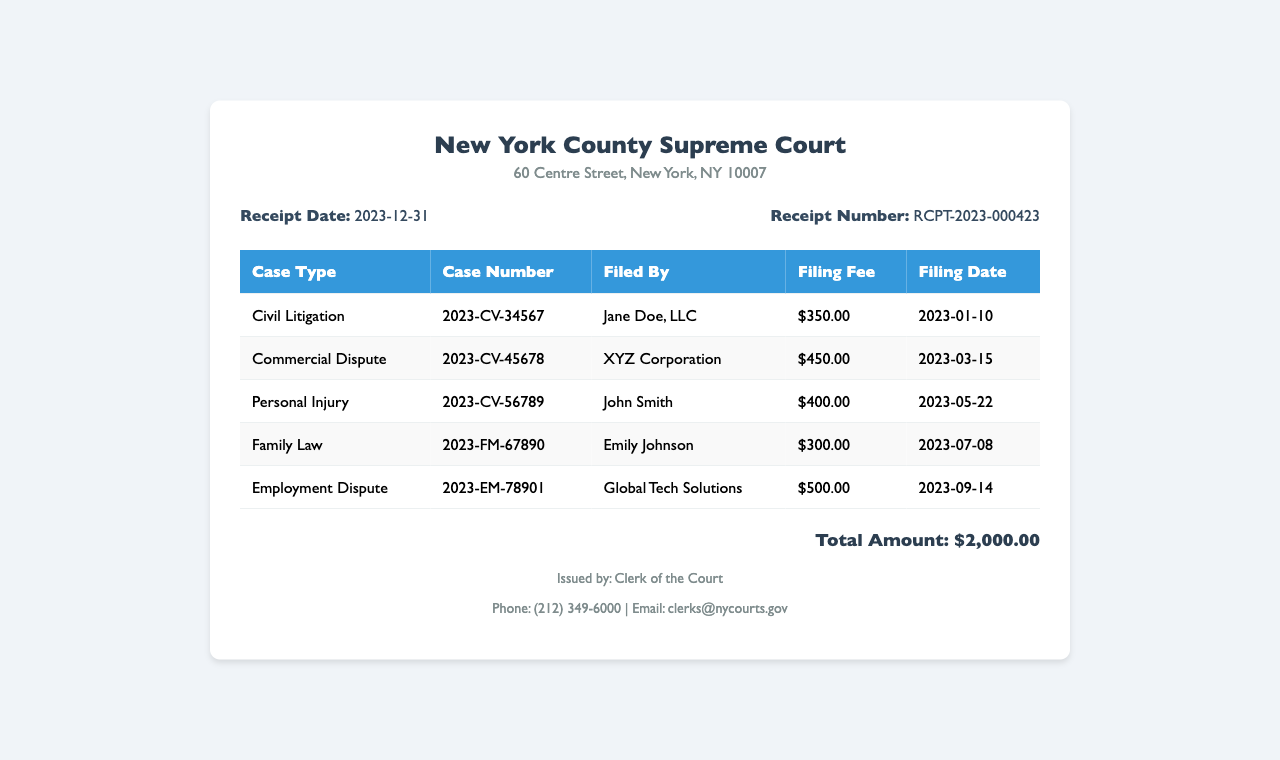What is the receipt date? The receipt date can be found in the receipt info section of the document, which states "Receipt Date: 2023-12-31."
Answer: 2023-12-31 What is the total amount of filing fees? The total amount is presented clearly at the bottom of the document as "Total Amount: $2,000.00."
Answer: $2,000.00 Who filed the Personal Injury case? The filing party for the Personal Injury case is listed under "Filed By" in the respective row as "John Smith."
Answer: John Smith How many case types are listed in the receipt? The receipt lists different case types in the table under the "Case Type" column. There are five unique entries.
Answer: 5 What is the filing fee for the Employment Dispute case? The fee for the Employment Dispute case is noted in the respective row as "$500.00."
Answer: $500.00 What is the case number for the Commercial Dispute case? The case number for the Commercial Dispute is provided in the table as "2023-CV-45678."
Answer: 2023-CV-45678 Which court issued this receipt? The issuing court is stated in the header of the document as "New York County Supreme Court."
Answer: New York County Supreme Court What filing date corresponds to the Civil Litigation case? The filing date for the Civil Litigation case can be found in the "Filing Date" column, which lists "2023-01-10."
Answer: 2023-01-10 What is the contact email for the Clerk of the Court? The contact email is provided in the footer of the document as "clerks@nycourts.gov."
Answer: clerks@nycourts.gov 